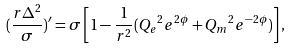Convert formula to latex. <formula><loc_0><loc_0><loc_500><loc_500>( \frac { r \Delta ^ { 2 } } { \sigma } ) ^ { \prime } = \sigma \left [ 1 - \frac { 1 } { r ^ { 2 } } ( { Q _ { e } } ^ { 2 } e ^ { 2 \phi } + { Q _ { m } } ^ { 2 } e ^ { - 2 \phi } ) \right ] ,</formula> 